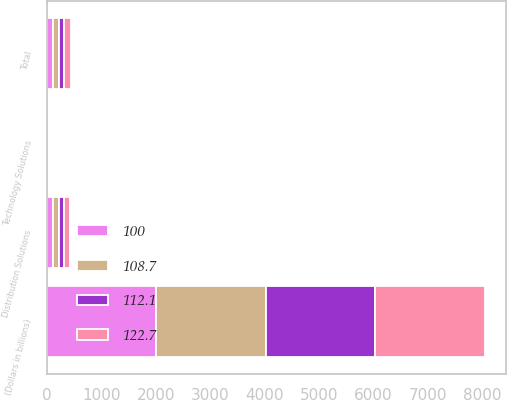<chart> <loc_0><loc_0><loc_500><loc_500><stacked_bar_chart><ecel><fcel>(Dollars in billions)<fcel>Distribution Solutions<fcel>Technology Solutions<fcel>Total<nl><fcel>122.7<fcel>2012<fcel>119.4<fcel>3.3<fcel>122.7<nl><fcel>112.1<fcel>2012<fcel>97<fcel>3<fcel>100<nl><fcel>100<fcel>2011<fcel>108.9<fcel>3.2<fcel>112.1<nl><fcel>108.7<fcel>2010<fcel>105.6<fcel>3.1<fcel>108.7<nl></chart> 